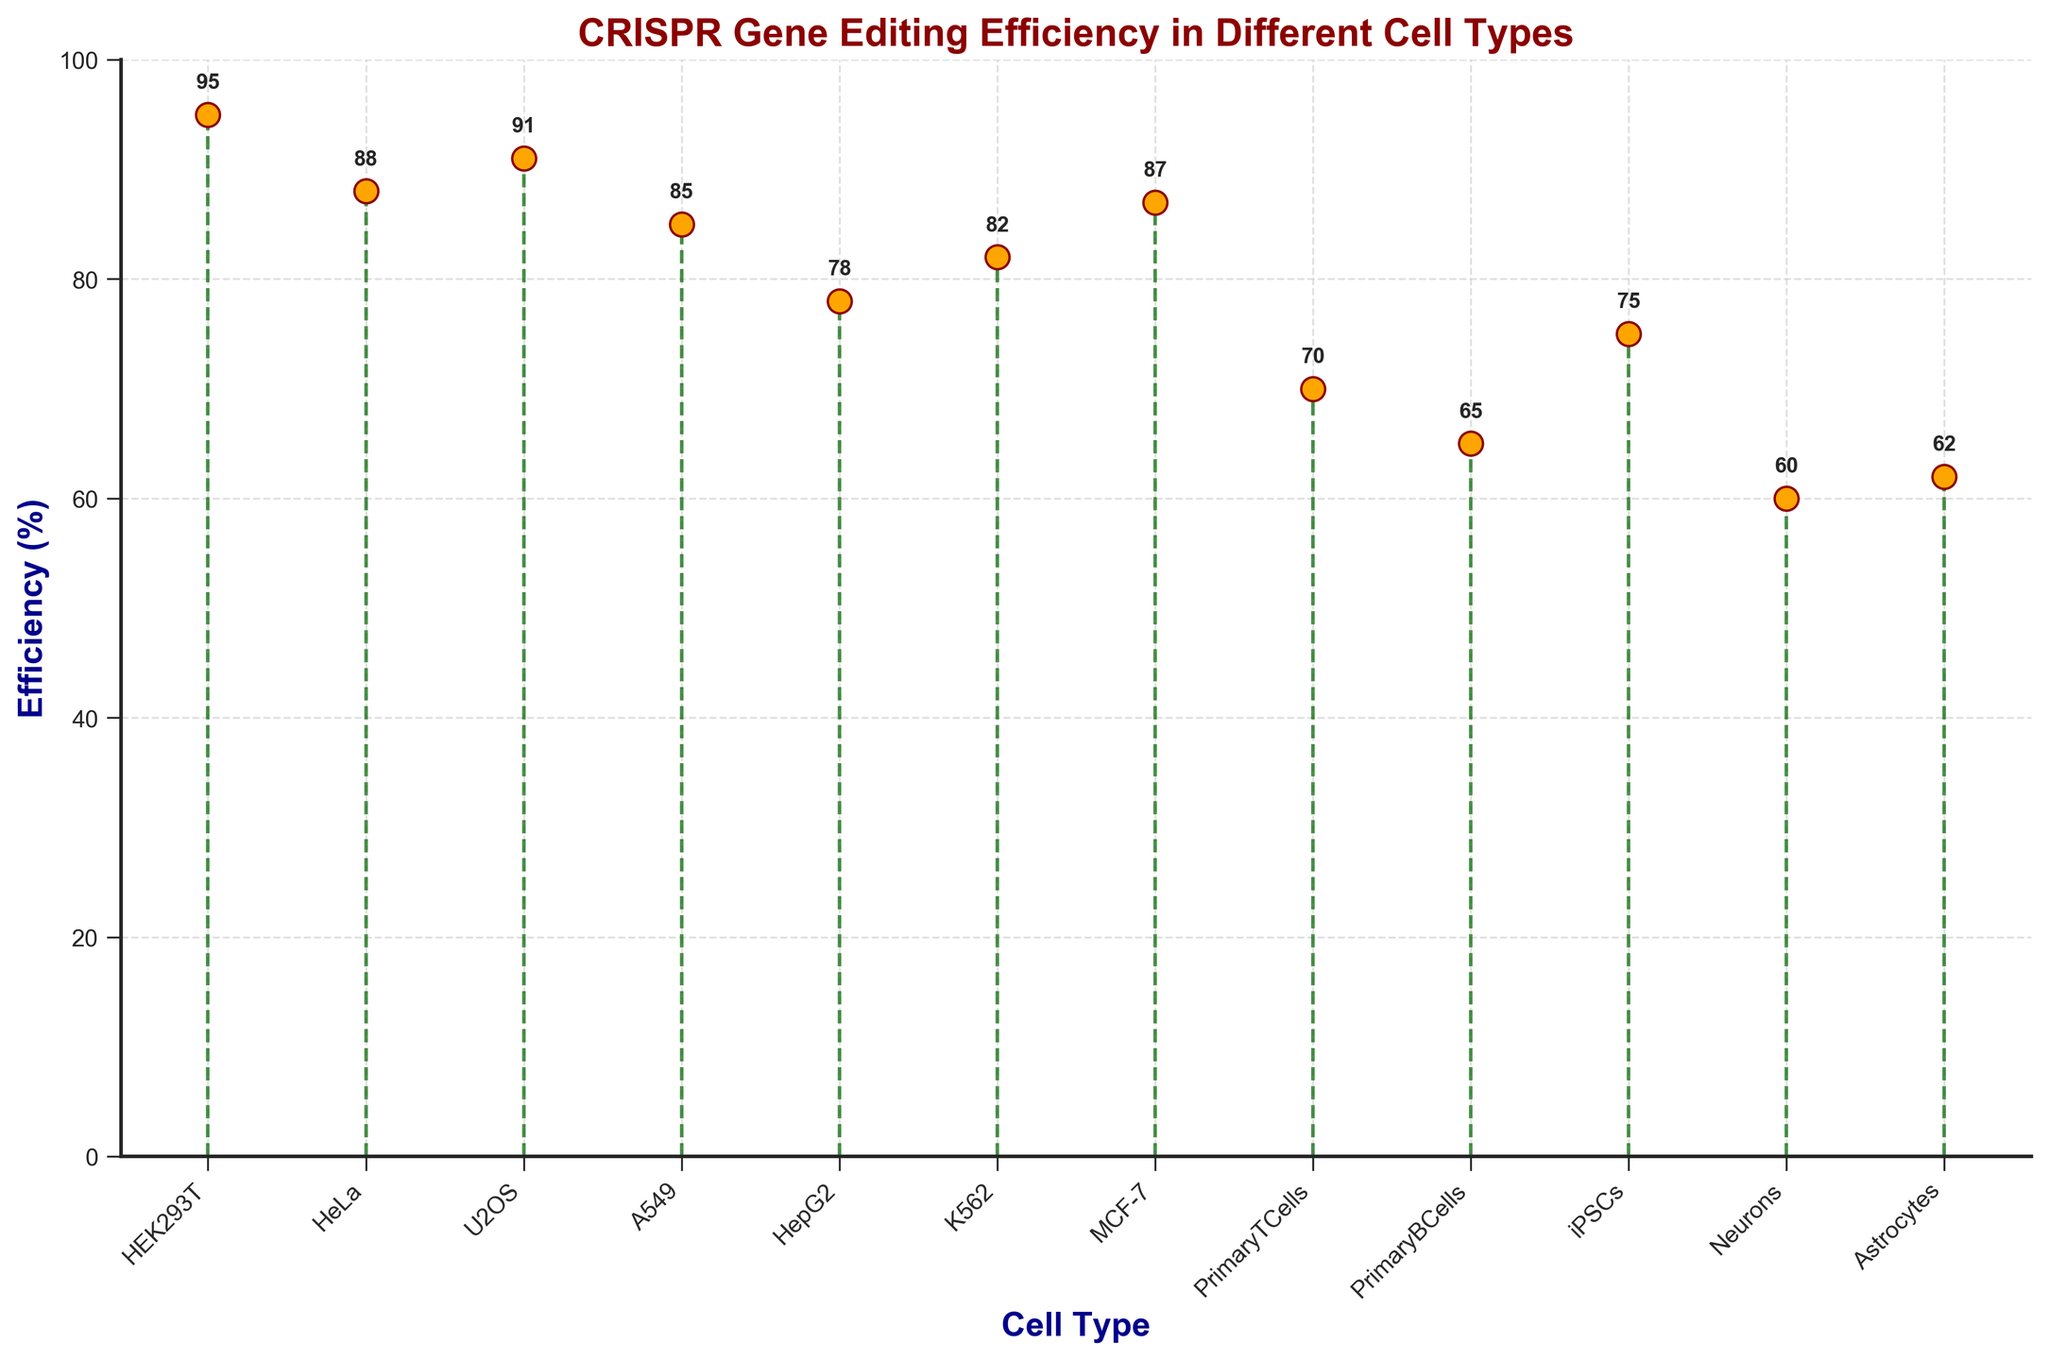What is the title of the figure? The title of the figure is displayed at the top of the plot. It reads "CRISPR Gene Editing Efficiency in Different Cell Types".
Answer: CRISPR Gene Editing Efficiency in Different Cell Types What do the y-axis labels represent? The y-axis labels represent the efficiency percentage of CRISPR gene editing in different cell types.
Answer: Efficiency percentage Which cell type shows the highest efficiency? The highest efficiency percentage is indicated by the tallest stem, which is labeled as 95%. HEK293T cells have this value.
Answer: HEK293T What is the efficiency of CRISPR gene editing in Primary B Cells? Locate the 'Primary B Cells' label on the x-axis and follow the stem line to its tip, which reads 65%.
Answer: 65% How many cell types have an efficiency greater than 80%? Count the number of stems representing efficiencies greater than 80%. There are 6 stems (HEK293T, HeLa, U2OS, A549, K562, MCF-7).
Answer: 6 Which cell type has the least efficiency and what is its value? The smallest stem represents the lowest efficiency percentage. This stem is labeled 'Neurons', with an efficiency of 60%.
Answer: Neurons, 60% What is the average efficiency of CRISPR gene editing for all cell types? Sum all the efficiency percentages and divide by the number of cell types: 
(95 + 88 + 91 + 85 + 78 + 82 + 87 + 70 + 65 + 75 + 60 + 62) / 12 = 78.5.
Answer: 78.5 How does the efficiency of CRISPR in Primary T Cells compare to that in iPSCs? Look at the values for Primary T Cells (70%) and iPSCs (75%). iPSCs have a higher efficiency by 5 percentage points.
Answer: iPSCs are higher by 5% What are the cell types with efficiencies below 75% and list their efficiencies? Identify and list the cell types whose efficiencies are less than 75%. These are Neurons (60%), Astrocytes (62%), Primary B Cells (65%), and Primary T Cells (70%).
Answer: Neurons: 60%, Astrocytes: 62%, Primary B Cells: 65%, Primary T Cells: 70% What is the difference in efficiency between HeLa and K562 cells? Find and subtract the efficiency values for K562 (82%) from HeLa (88%): 88 - 82 = 6%.
Answer: 6% 